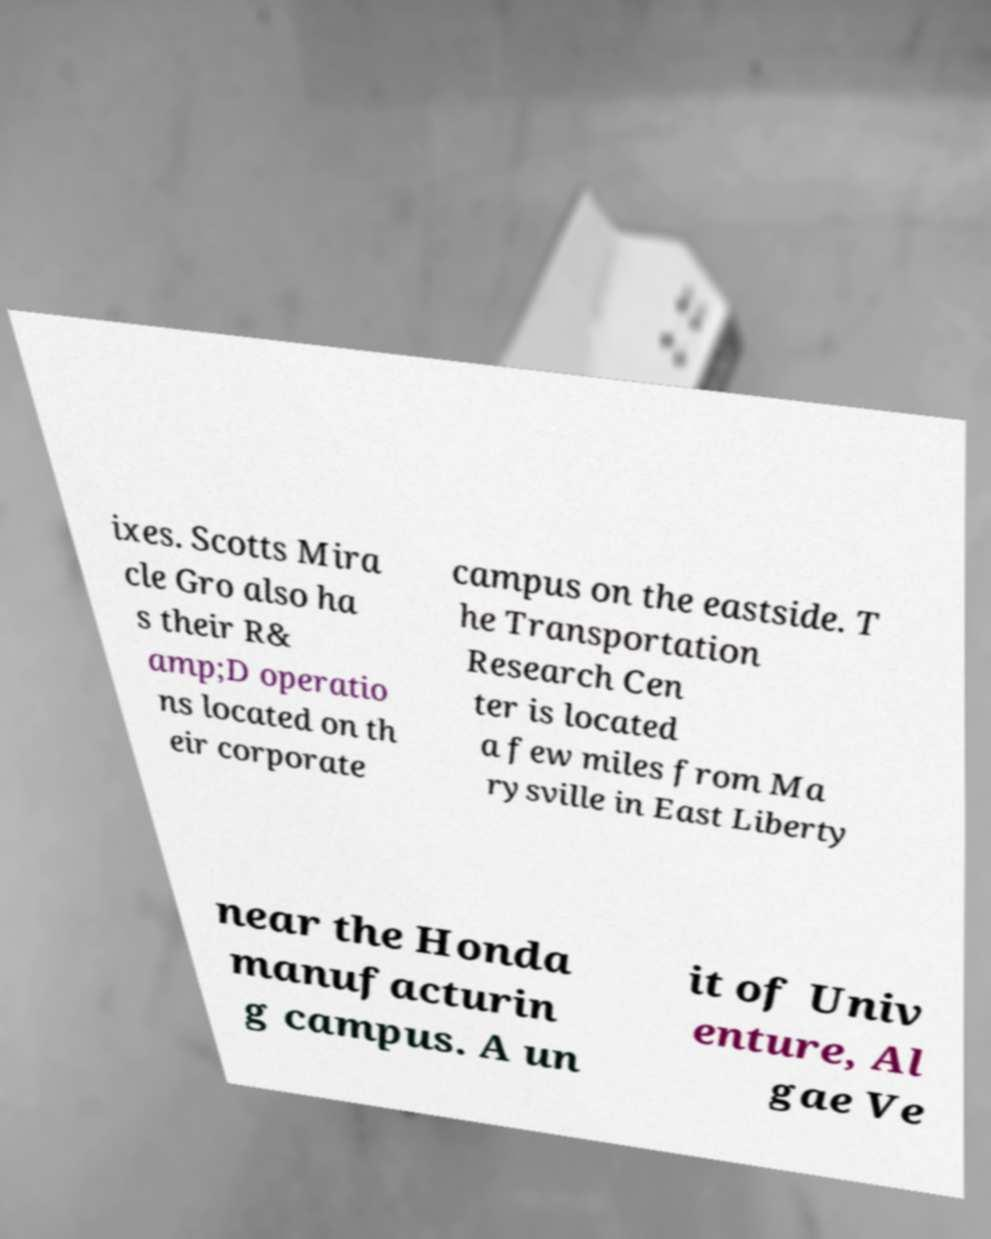There's text embedded in this image that I need extracted. Can you transcribe it verbatim? ixes. Scotts Mira cle Gro also ha s their R& amp;D operatio ns located on th eir corporate campus on the eastside. T he Transportation Research Cen ter is located a few miles from Ma rysville in East Liberty near the Honda manufacturin g campus. A un it of Univ enture, Al gae Ve 